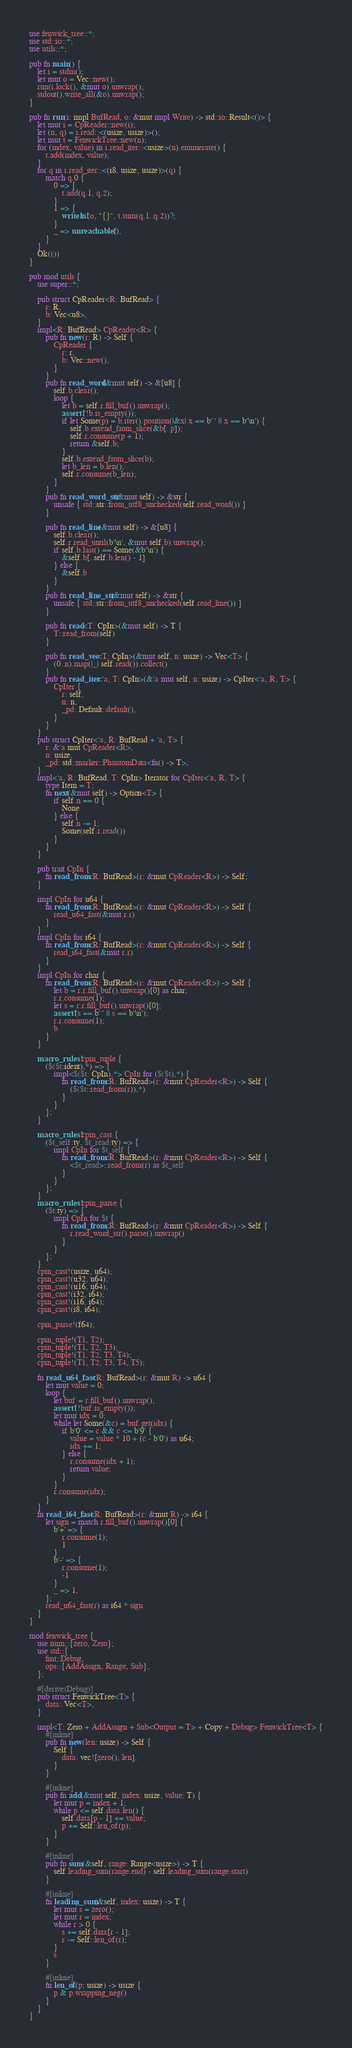Convert code to text. <code><loc_0><loc_0><loc_500><loc_500><_Rust_>use fenwick_tree::*;
use std::io::*;
use utils::*;

pub fn main() {
    let i = stdin();
    let mut o = Vec::new();
    run(i.lock(), &mut o).unwrap();
    stdout().write_all(&o).unwrap();
}

pub fn run(i: impl BufRead, o: &mut impl Write) -> std::io::Result<()> {
    let mut i = CpReader::new(i);
    let (n, q) = i.read::<(usize, usize)>();
    let mut t = FenwickTree::new(n);
    for (index, value) in i.read_iter::<usize>(n).enumerate() {
        t.add(index, value);
    }
    for q in i.read_iter::<(i8, usize, usize)>(q) {
        match q.0 {
            0 => {
                t.add(q.1, q.2);
            }
            1 => {
                writeln!(o, "{}", t.sum(q.1..q.2))?;
            }
            _ => unreachable!(),
        }
    }
    Ok(())
}

pub mod utils {
    use super::*;

    pub struct CpReader<R: BufRead> {
        r: R,
        b: Vec<u8>,
    }
    impl<R: BufRead> CpReader<R> {
        pub fn new(r: R) -> Self {
            CpReader {
                r: r,
                b: Vec::new(),
            }
        }
        pub fn read_word(&mut self) -> &[u8] {
            self.b.clear();
            loop {
                let b = self.r.fill_buf().unwrap();
                assert!(!b.is_empty());
                if let Some(p) = b.iter().position(|&x| x == b' ' || x == b'\n') {
                    self.b.extend_from_slice(&b[..p]);
                    self.r.consume(p + 1);
                    return &self.b;
                }
                self.b.extend_from_slice(b);
                let b_len = b.len();
                self.r.consume(b_len);
            }
        }
        pub fn read_word_str(&mut self) -> &str {
            unsafe { std::str::from_utf8_unchecked(self.read_word()) }
        }

        pub fn read_line(&mut self) -> &[u8] {
            self.b.clear();
            self.r.read_until(b'\n', &mut self.b).unwrap();
            if self.b.last() == Some(&b'\n') {
                &self.b[..self.b.len() - 1]
            } else {
                &self.b
            }
        }
        pub fn read_line_str(&mut self) -> &str {
            unsafe { std::str::from_utf8_unchecked(self.read_line()) }
        }

        pub fn read<T: CpIn>(&mut self) -> T {
            T::read_from(self)
        }

        pub fn read_vec<T: CpIn>(&mut self, n: usize) -> Vec<T> {
            (0..n).map(|_| self.read()).collect()
        }
        pub fn read_iter<'a, T: CpIn>(&'a mut self, n: usize) -> CpIter<'a, R, T> {
            CpIter {
                r: self,
                n: n,
                _pd: Default::default(),
            }
        }
    }
    pub struct CpIter<'a, R: BufRead + 'a, T> {
        r: &'a mut CpReader<R>,
        n: usize,
        _pd: std::marker::PhantomData<fn() -> T>,
    }
    impl<'a, R: BufRead, T: CpIn> Iterator for CpIter<'a, R, T> {
        type Item = T;
        fn next(&mut self) -> Option<T> {
            if self.n == 0 {
                None
            } else {
                self.n -= 1;
                Some(self.r.read())
            }
        }
    }

    pub trait CpIn {
        fn read_from<R: BufRead>(r: &mut CpReader<R>) -> Self;
    }

    impl CpIn for u64 {
        fn read_from<R: BufRead>(r: &mut CpReader<R>) -> Self {
            read_u64_fast(&mut r.r)
        }
    }
    impl CpIn for i64 {
        fn read_from<R: BufRead>(r: &mut CpReader<R>) -> Self {
            read_i64_fast(&mut r.r)
        }
    }
    impl CpIn for char {
        fn read_from<R: BufRead>(r: &mut CpReader<R>) -> Self {
            let b = r.r.fill_buf().unwrap()[0] as char;
            r.r.consume(1);
            let s = r.r.fill_buf().unwrap()[0];
            assert!(s == b' ' || s == b'\n');
            r.r.consume(1);
            b
        }
    }

    macro_rules! cpin_tuple {
        ($($t:ident),*) => {
            impl<$($t: CpIn),*> CpIn for ($($t),*) {
                fn read_from<R: BufRead>(r: &mut CpReader<R>) -> Self {
                    ($($t::read_from(r)),*)
                }
            }
        };
    }

    macro_rules! cpin_cast {
        ($t_self:ty, $t_read:ty) => {
            impl CpIn for $t_self {
                fn read_from<R: BufRead>(r: &mut CpReader<R>) -> Self {
                    <$t_read>::read_from(r) as $t_self
                }
            }
        };
    }
    macro_rules! cpin_parse {
        ($t:ty) => {
            impl CpIn for $t {
                fn read_from<R: BufRead>(r: &mut CpReader<R>) -> Self {
                    r.read_word_str().parse().unwrap()
                }
            }
        };
    }
    cpin_cast!(usize, u64);
    cpin_cast!(u32, u64);
    cpin_cast!(u16, u64);
    cpin_cast!(i32, i64);
    cpin_cast!(i16, i64);
    cpin_cast!(i8, i64);

    cpin_parse!(f64);

    cpin_tuple!(T1, T2);
    cpin_tuple!(T1, T2, T3);
    cpin_tuple!(T1, T2, T3, T4);
    cpin_tuple!(T1, T2, T3, T4, T5);

    fn read_u64_fast<R: BufRead>(r: &mut R) -> u64 {
        let mut value = 0;
        loop {
            let buf = r.fill_buf().unwrap();
            assert!(!buf.is_empty());
            let mut idx = 0;
            while let Some(&c) = buf.get(idx) {
                if b'0' <= c && c <= b'9' {
                    value = value * 10 + (c - b'0') as u64;
                    idx += 1;
                } else {
                    r.consume(idx + 1);
                    return value;
                }
            }
            r.consume(idx);
        }
    }
    fn read_i64_fast<R: BufRead>(r: &mut R) -> i64 {
        let sign = match r.fill_buf().unwrap()[0] {
            b'+' => {
                r.consume(1);
                1
            }
            b'-' => {
                r.consume(1);
                -1
            }
            _ => 1,
        };
        read_u64_fast(r) as i64 * sign
    }
}

mod fenwick_tree {
    use num::{zero, Zero};
    use std::{
        fmt::Debug,
        ops::{AddAssign, Range, Sub},
    };

    #[derive(Debug)]
    pub struct FenwickTree<T> {
        data: Vec<T>,
    }

    impl<T: Zero + AddAssign + Sub<Output = T> + Copy + Debug> FenwickTree<T> {
        #[inline]
        pub fn new(len: usize) -> Self {
            Self {
                data: vec![zero(); len],
            }
        }

        #[inline]
        pub fn add(&mut self, index: usize, value: T) {
            let mut p = index + 1;
            while p <= self.data.len() {
                self.data[p - 1] += value;
                p += Self::len_of(p);
            }
        }

        #[inline]
        pub fn sum(&self, range: Range<usize>) -> T {
            self.leading_sum(range.end) - self.leading_sum(range.start)
        }

        #[inline]
        fn leading_sum(&self, index: usize) -> T {
            let mut s = zero();
            let mut r = index;
            while r > 0 {
                s += self.data[r - 1];
                r -= Self::len_of(r);
            }
            s
        }

        #[inline]
        fn len_of(p: usize) -> usize {
            p & p.wrapping_neg()
        }
    }
}
</code> 